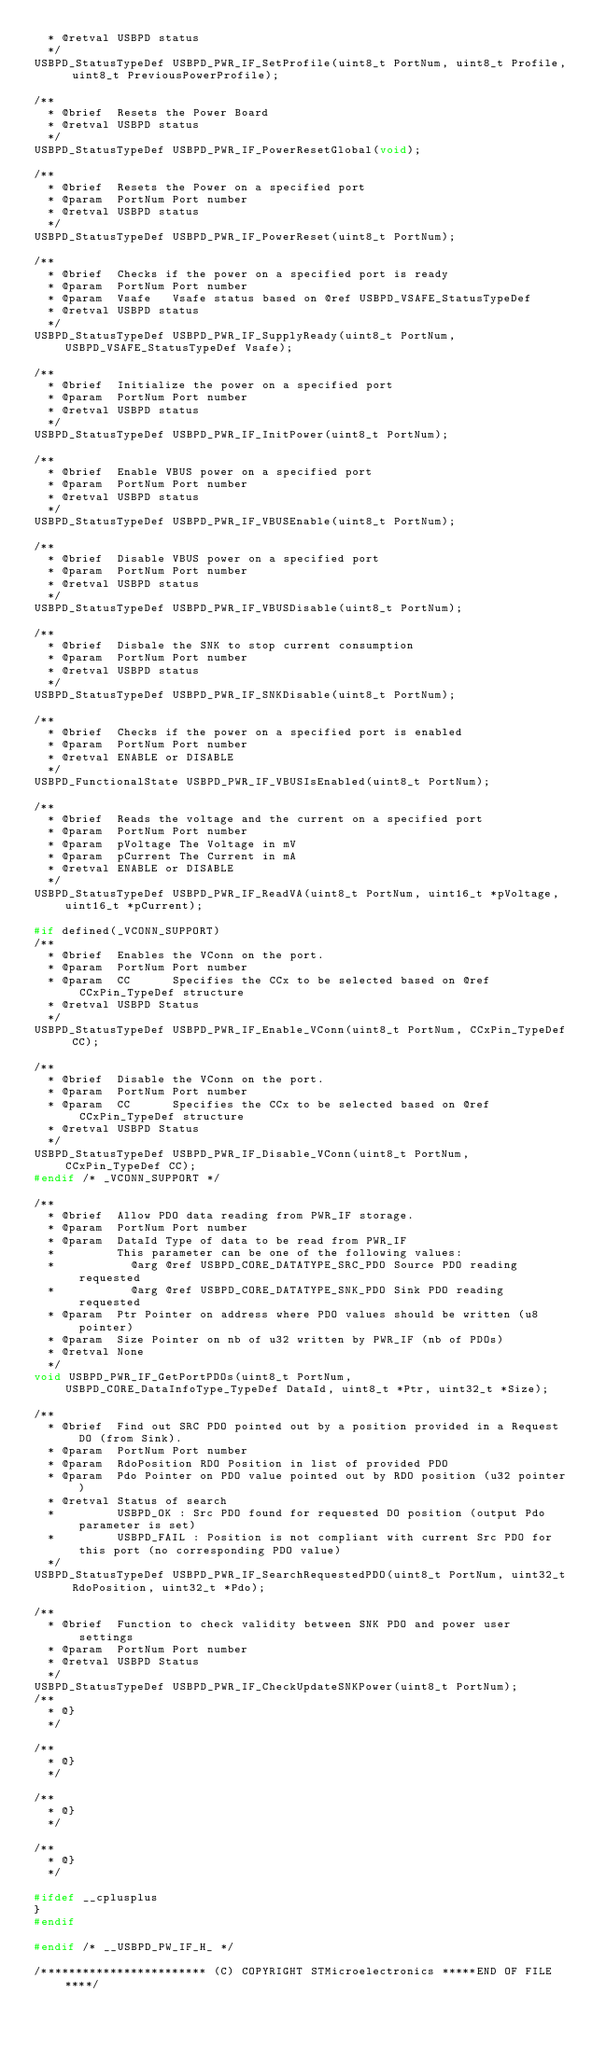<code> <loc_0><loc_0><loc_500><loc_500><_C_>  * @retval USBPD status
  */
USBPD_StatusTypeDef USBPD_PWR_IF_SetProfile(uint8_t PortNum, uint8_t Profile, uint8_t PreviousPowerProfile);

/**
  * @brief  Resets the Power Board
  * @retval USBPD status
  */
USBPD_StatusTypeDef USBPD_PWR_IF_PowerResetGlobal(void);

/**
  * @brief  Resets the Power on a specified port
  * @param  PortNum Port number
  * @retval USBPD status
  */
USBPD_StatusTypeDef USBPD_PWR_IF_PowerReset(uint8_t PortNum);

/**
  * @brief  Checks if the power on a specified port is ready
  * @param  PortNum Port number
  * @param  Vsafe   Vsafe status based on @ref USBPD_VSAFE_StatusTypeDef
  * @retval USBPD status
  */
USBPD_StatusTypeDef USBPD_PWR_IF_SupplyReady(uint8_t PortNum, USBPD_VSAFE_StatusTypeDef Vsafe);

/**
  * @brief  Initialize the power on a specified port
  * @param  PortNum Port number
  * @retval USBPD status
  */
USBPD_StatusTypeDef USBPD_PWR_IF_InitPower(uint8_t PortNum);

/**
  * @brief  Enable VBUS power on a specified port
  * @param  PortNum Port number
  * @retval USBPD status
  */
USBPD_StatusTypeDef USBPD_PWR_IF_VBUSEnable(uint8_t PortNum);

/**
  * @brief  Disable VBUS power on a specified port
  * @param  PortNum Port number
  * @retval USBPD status
  */
USBPD_StatusTypeDef USBPD_PWR_IF_VBUSDisable(uint8_t PortNum);

/**
  * @brief  Disbale the SNK to stop current consumption 
  * @param  PortNum Port number
  * @retval USBPD status
  */
USBPD_StatusTypeDef USBPD_PWR_IF_SNKDisable(uint8_t PortNum);

/**
  * @brief  Checks if the power on a specified port is enabled
  * @param  PortNum Port number
  * @retval ENABLE or DISABLE
  */
USBPD_FunctionalState USBPD_PWR_IF_VBUSIsEnabled(uint8_t PortNum);

/**
  * @brief  Reads the voltage and the current on a specified port
  * @param  PortNum Port number
  * @param  pVoltage The Voltage in mV
  * @param  pCurrent The Current in mA
  * @retval ENABLE or DISABLE
  */
USBPD_StatusTypeDef USBPD_PWR_IF_ReadVA(uint8_t PortNum, uint16_t *pVoltage, uint16_t *pCurrent);

#if defined(_VCONN_SUPPORT)
/**
  * @brief  Enables the VConn on the port.
  * @param  PortNum Port number
  * @param  CC      Specifies the CCx to be selected based on @ref CCxPin_TypeDef structure
  * @retval USBPD Status
  */
USBPD_StatusTypeDef USBPD_PWR_IF_Enable_VConn(uint8_t PortNum, CCxPin_TypeDef CC);

/**
  * @brief  Disable the VConn on the port.
  * @param  PortNum Port number
  * @param  CC      Specifies the CCx to be selected based on @ref CCxPin_TypeDef structure
  * @retval USBPD Status
  */
USBPD_StatusTypeDef USBPD_PWR_IF_Disable_VConn(uint8_t PortNum, CCxPin_TypeDef CC);
#endif /* _VCONN_SUPPORT */

/**
  * @brief  Allow PDO data reading from PWR_IF storage.
  * @param  PortNum Port number
  * @param  DataId Type of data to be read from PWR_IF
  *         This parameter can be one of the following values:
  *           @arg @ref USBPD_CORE_DATATYPE_SRC_PDO Source PDO reading requested
  *           @arg @ref USBPD_CORE_DATATYPE_SNK_PDO Sink PDO reading requested
  * @param  Ptr Pointer on address where PDO values should be written (u8 pointer)
  * @param  Size Pointer on nb of u32 written by PWR_IF (nb of PDOs)
  * @retval None
  */
void USBPD_PWR_IF_GetPortPDOs(uint8_t PortNum, USBPD_CORE_DataInfoType_TypeDef DataId, uint8_t *Ptr, uint32_t *Size);

/**
  * @brief  Find out SRC PDO pointed out by a position provided in a Request DO (from Sink).
  * @param  PortNum Port number
  * @param  RdoPosition RDO Position in list of provided PDO
  * @param  Pdo Pointer on PDO value pointed out by RDO position (u32 pointer)
  * @retval Status of search
  *         USBPD_OK : Src PDO found for requested DO position (output Pdo parameter is set)
  *         USBPD_FAIL : Position is not compliant with current Src PDO for this port (no corresponding PDO value)
  */
USBPD_StatusTypeDef USBPD_PWR_IF_SearchRequestedPDO(uint8_t PortNum, uint32_t RdoPosition, uint32_t *Pdo);

/**
  * @brief  Function to check validity between SNK PDO and power user settings
  * @param  PortNum Port number
  * @retval USBPD Status
  */
USBPD_StatusTypeDef USBPD_PWR_IF_CheckUpdateSNKPower(uint8_t PortNum);
/**
  * @}
  */

/**
  * @}
  */

/**
  * @}
  */

/**
  * @}
  */

#ifdef __cplusplus
}
#endif

#endif /* __USBPD_PW_IF_H_ */

/************************ (C) COPYRIGHT STMicroelectronics *****END OF FILE****/

</code> 